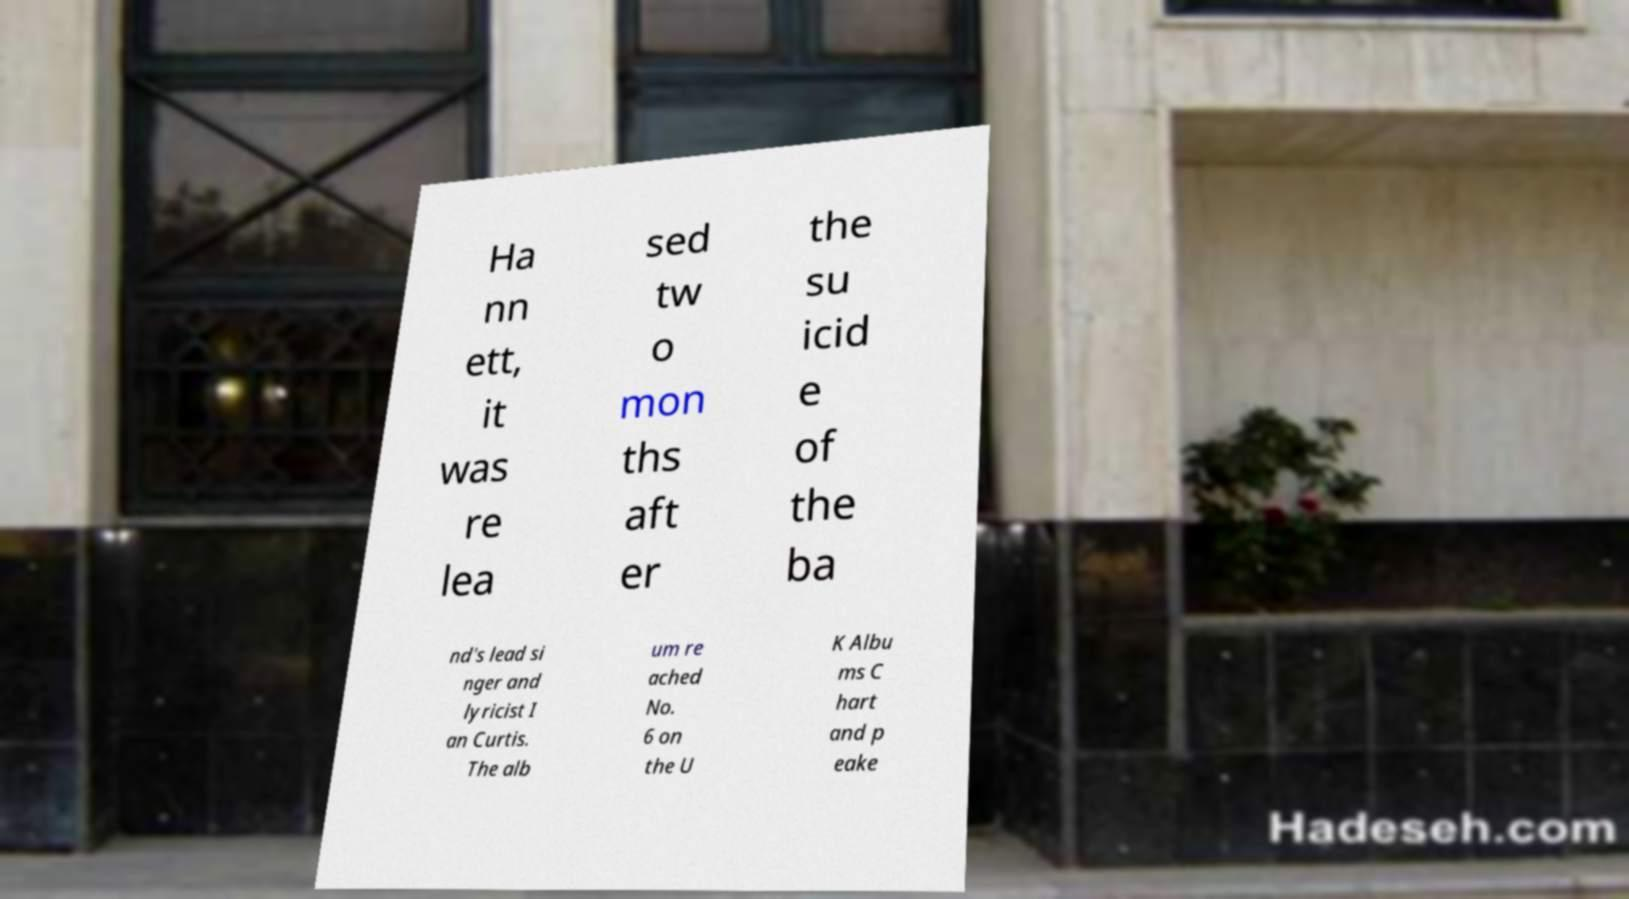Please identify and transcribe the text found in this image. Ha nn ett, it was re lea sed tw o mon ths aft er the su icid e of the ba nd's lead si nger and lyricist I an Curtis. The alb um re ached No. 6 on the U K Albu ms C hart and p eake 